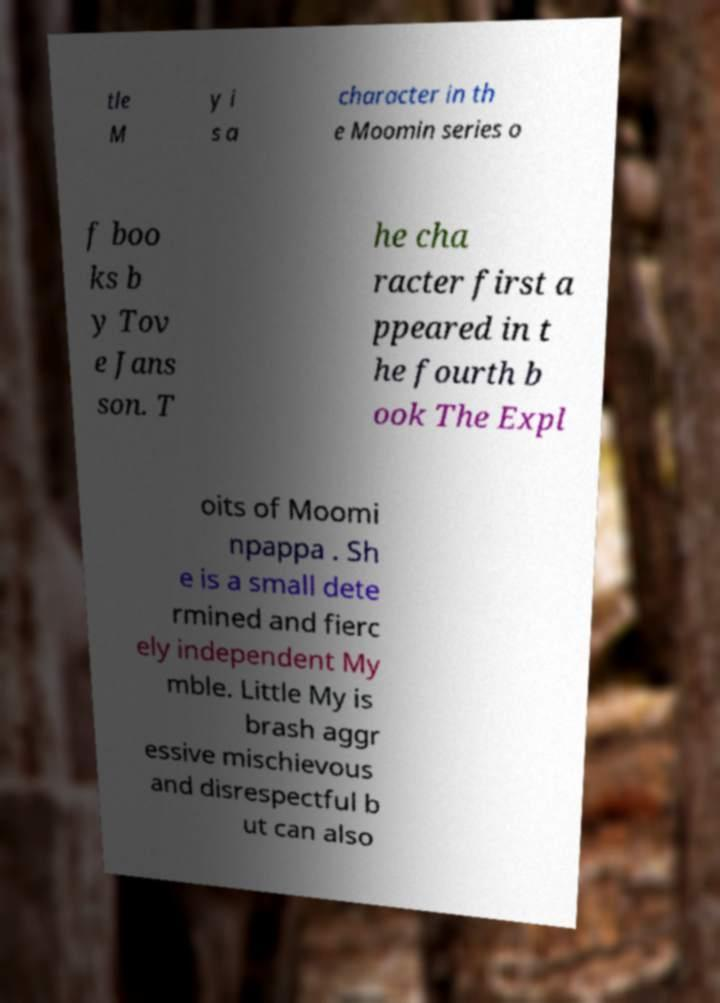For documentation purposes, I need the text within this image transcribed. Could you provide that? tle M y i s a character in th e Moomin series o f boo ks b y Tov e Jans son. T he cha racter first a ppeared in t he fourth b ook The Expl oits of Moomi npappa . Sh e is a small dete rmined and fierc ely independent My mble. Little My is brash aggr essive mischievous and disrespectful b ut can also 